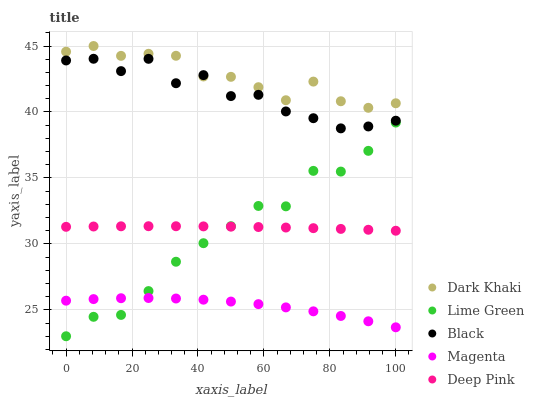Does Magenta have the minimum area under the curve?
Answer yes or no. Yes. Does Dark Khaki have the maximum area under the curve?
Answer yes or no. Yes. Does Black have the minimum area under the curve?
Answer yes or no. No. Does Black have the maximum area under the curve?
Answer yes or no. No. Is Deep Pink the smoothest?
Answer yes or no. Yes. Is Black the roughest?
Answer yes or no. Yes. Is Magenta the smoothest?
Answer yes or no. No. Is Magenta the roughest?
Answer yes or no. No. Does Lime Green have the lowest value?
Answer yes or no. Yes. Does Black have the lowest value?
Answer yes or no. No. Does Dark Khaki have the highest value?
Answer yes or no. Yes. Does Black have the highest value?
Answer yes or no. No. Is Deep Pink less than Black?
Answer yes or no. Yes. Is Dark Khaki greater than Deep Pink?
Answer yes or no. Yes. Does Deep Pink intersect Lime Green?
Answer yes or no. Yes. Is Deep Pink less than Lime Green?
Answer yes or no. No. Is Deep Pink greater than Lime Green?
Answer yes or no. No. Does Deep Pink intersect Black?
Answer yes or no. No. 